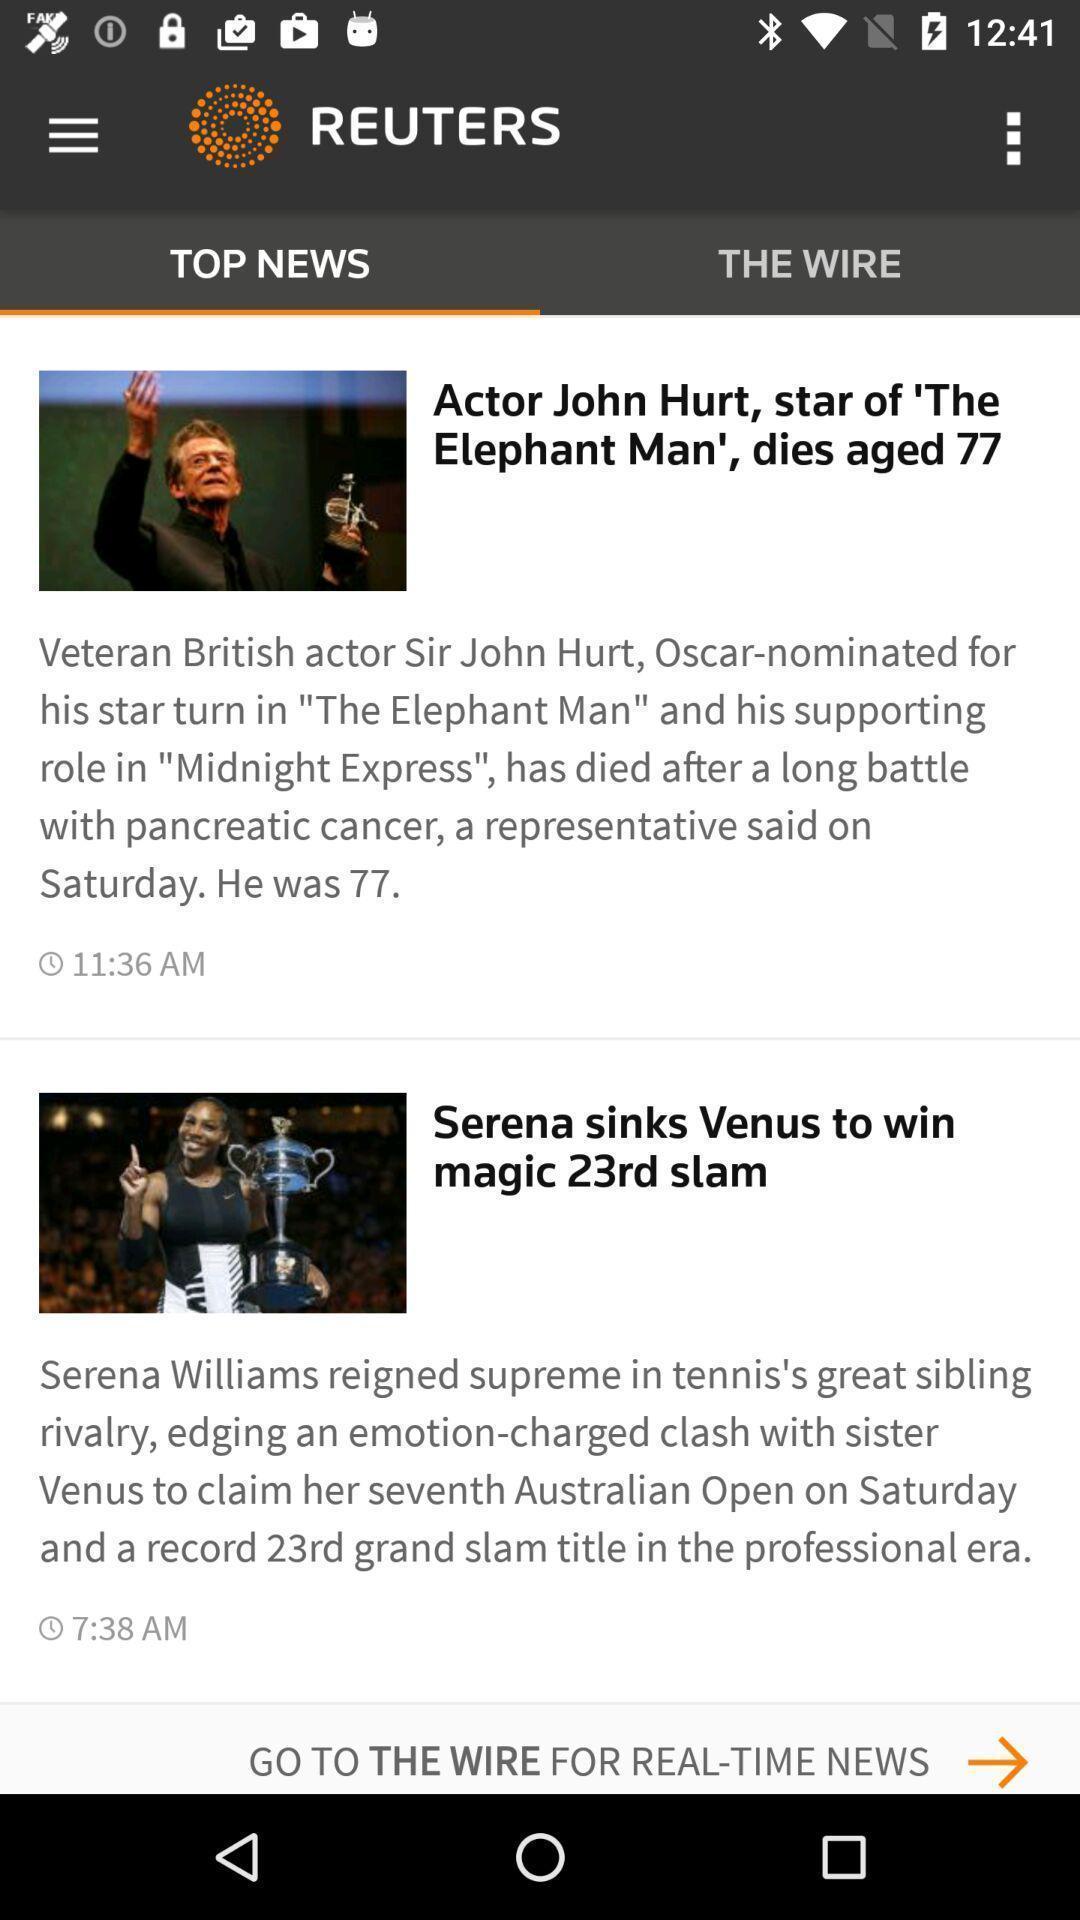Give me a summary of this screen capture. Page displaying top news on a news app. 